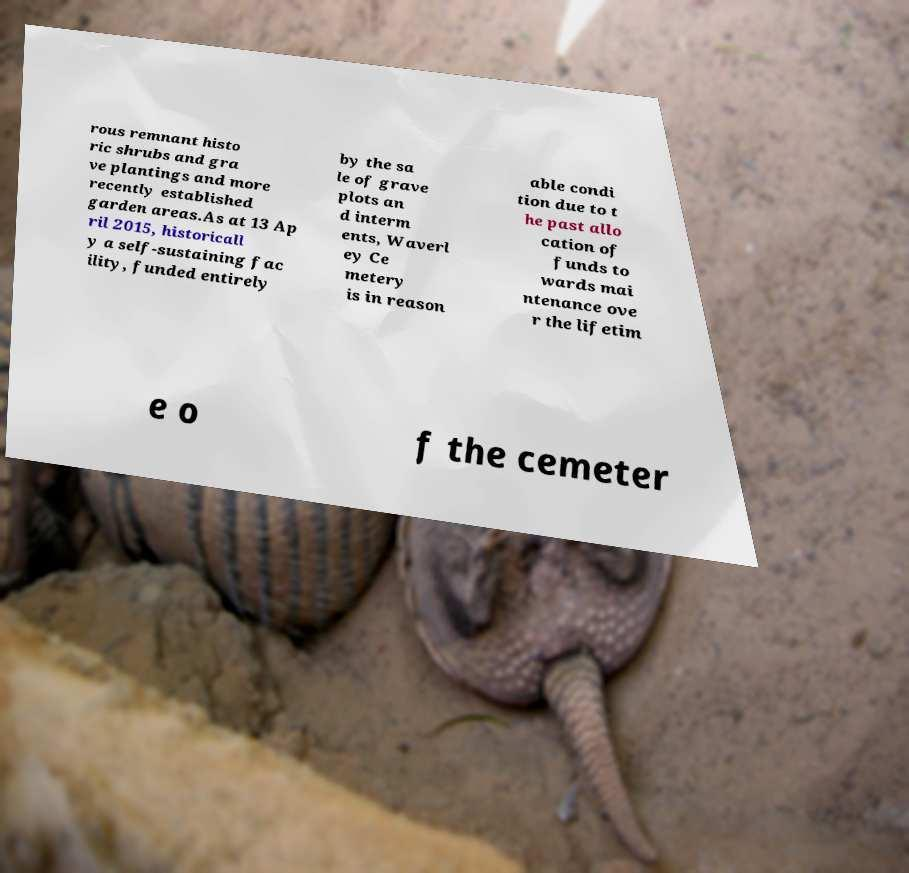There's text embedded in this image that I need extracted. Can you transcribe it verbatim? rous remnant histo ric shrubs and gra ve plantings and more recently established garden areas.As at 13 Ap ril 2015, historicall y a self-sustaining fac ility, funded entirely by the sa le of grave plots an d interm ents, Waverl ey Ce metery is in reason able condi tion due to t he past allo cation of funds to wards mai ntenance ove r the lifetim e o f the cemeter 